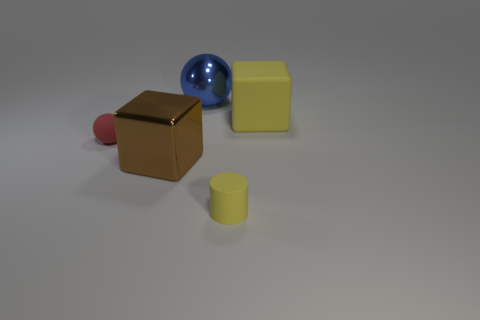Add 3 large purple matte cylinders. How many objects exist? 8 Subtract all cylinders. How many objects are left? 4 Subtract 1 brown blocks. How many objects are left? 4 Subtract all big rubber cubes. Subtract all red matte spheres. How many objects are left? 3 Add 1 blue metal balls. How many blue metal balls are left? 2 Add 4 big matte cubes. How many big matte cubes exist? 5 